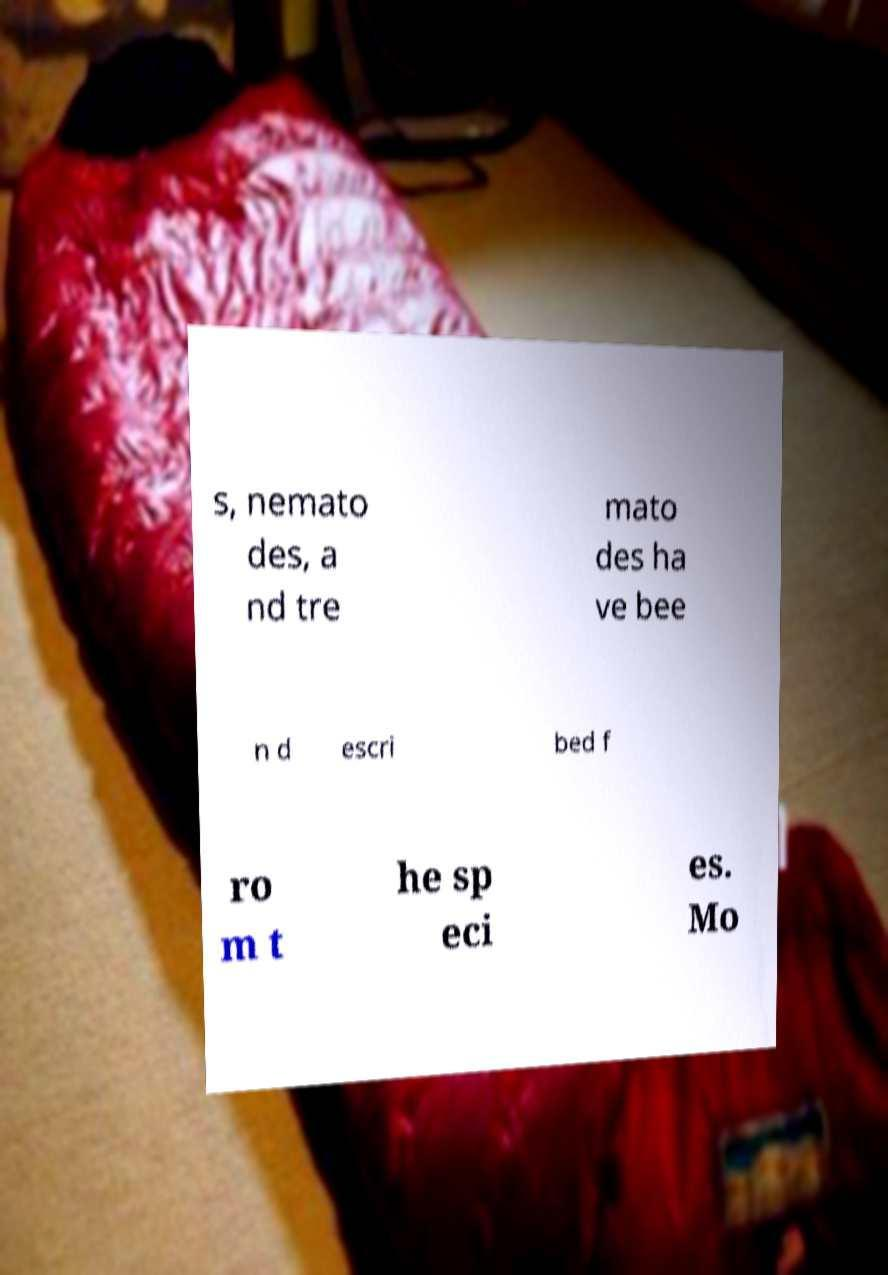Please identify and transcribe the text found in this image. s, nemato des, a nd tre mato des ha ve bee n d escri bed f ro m t he sp eci es. Mo 